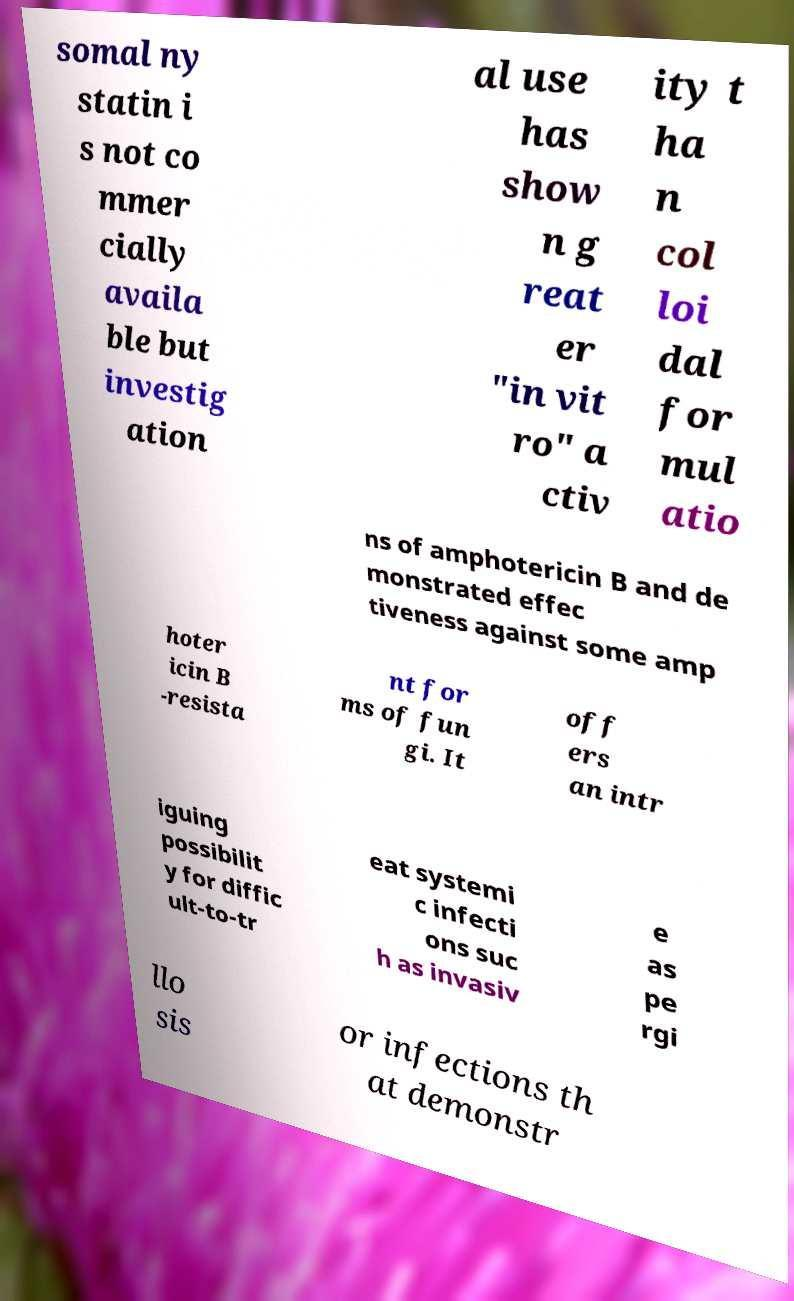There's text embedded in this image that I need extracted. Can you transcribe it verbatim? somal ny statin i s not co mmer cially availa ble but investig ation al use has show n g reat er "in vit ro" a ctiv ity t ha n col loi dal for mul atio ns of amphotericin B and de monstrated effec tiveness against some amp hoter icin B -resista nt for ms of fun gi. It off ers an intr iguing possibilit y for diffic ult-to-tr eat systemi c infecti ons suc h as invasiv e as pe rgi llo sis or infections th at demonstr 